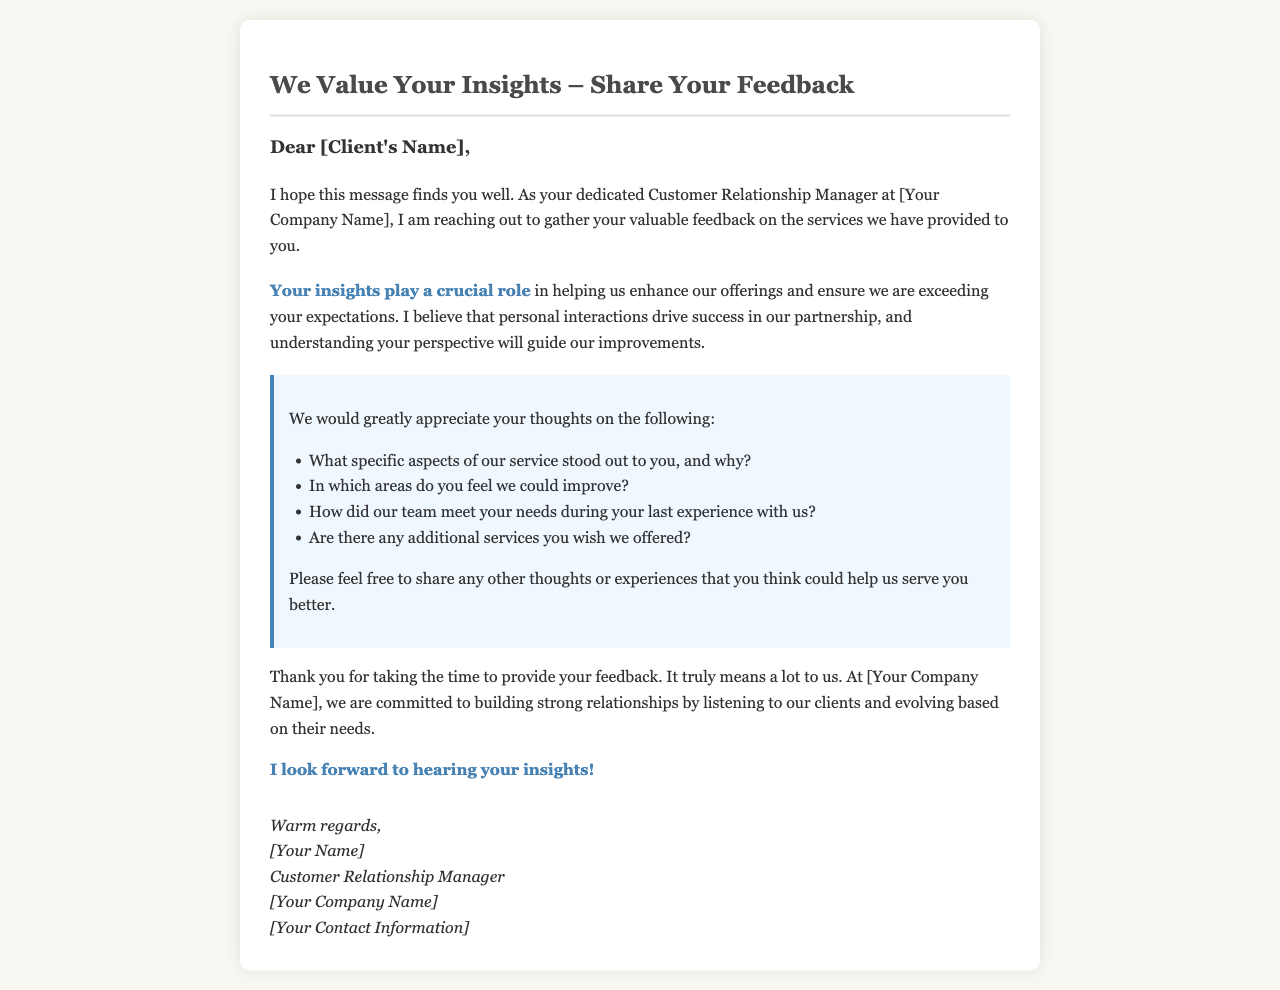What is the title of the document? The title of the document is displayed prominently at the top and sets the tone for the request.
Answer: We Value Your Insights – Share Your Feedback Who is the recipient of the letter? The letter addresses a specific client, indicated by a placeholder for their name.
Answer: [Client's Name] What role does the sender hold? The sender's position is mentioned in the signature of the letter.
Answer: Customer Relationship Manager Which company is mentioned in the document? The company's name is referenced multiple times in the letter.
Answer: [Your Company Name] What aspect of the service is highlighted as crucial for improvements? The letter emphasizes the importance of client opinions during feedback collection.
Answer: Your insights play a crucial role What are clients encouraged to share in addition to specific questions? The document invites clients to provide general thoughts or experiences beyond structured questions.
Answer: Any other thoughts or experiences How many questions are listed for client feedback? The letter provides a specific number of prompts for responses, indicating the focus areas for feedback.
Answer: Four What is the tone of the closing remarks? The closing section reflects a friendly and appreciative tone towards the recipient.
Answer: Warm regards What type of document is this? This document falls under a specific category aimed at gathering feedback from clients.
Answer: Client Feedback Request Letter 